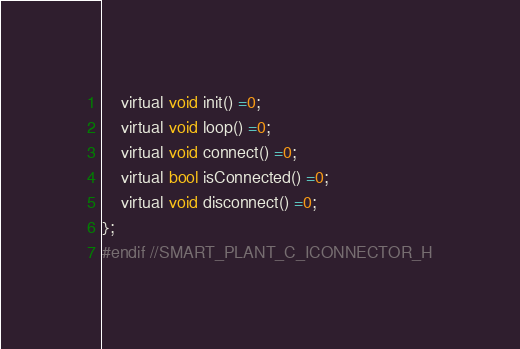Convert code to text. <code><loc_0><loc_0><loc_500><loc_500><_C_>    virtual void init() =0;
    virtual void loop() =0;
    virtual void connect() =0;
    virtual bool isConnected() =0;
    virtual void disconnect() =0;
};
#endif //SMART_PLANT_C_ICONNECTOR_H
</code> 